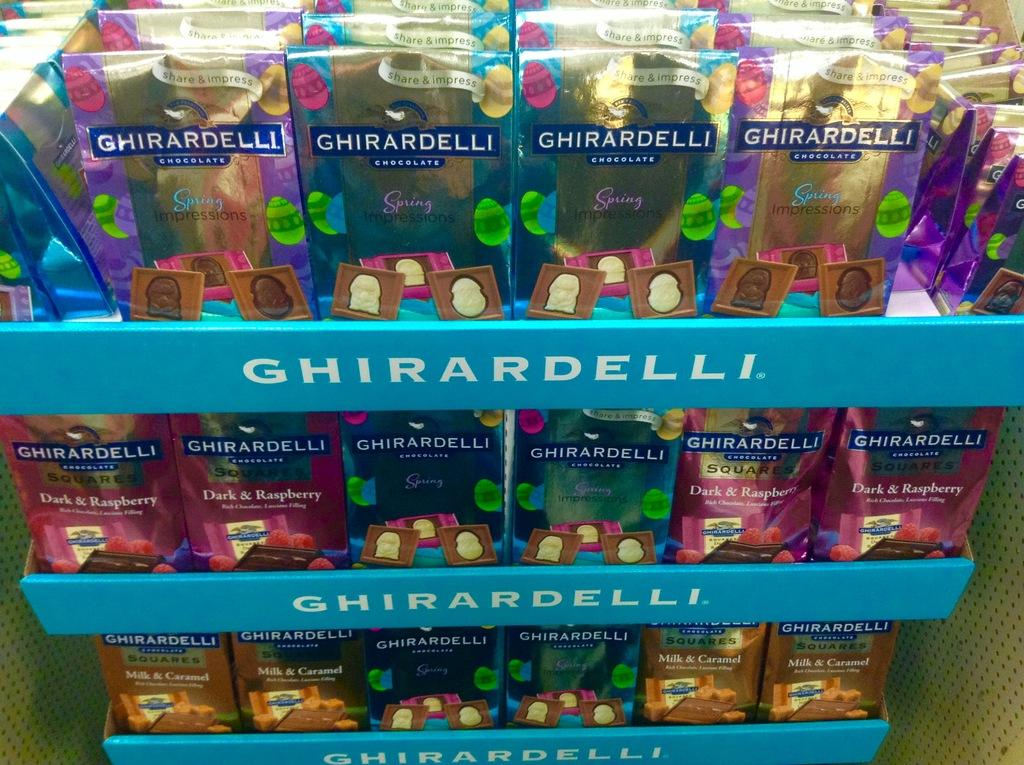<image>
Write a terse but informative summary of the picture. a ghirardelli display has several kinds of chocolate on it 